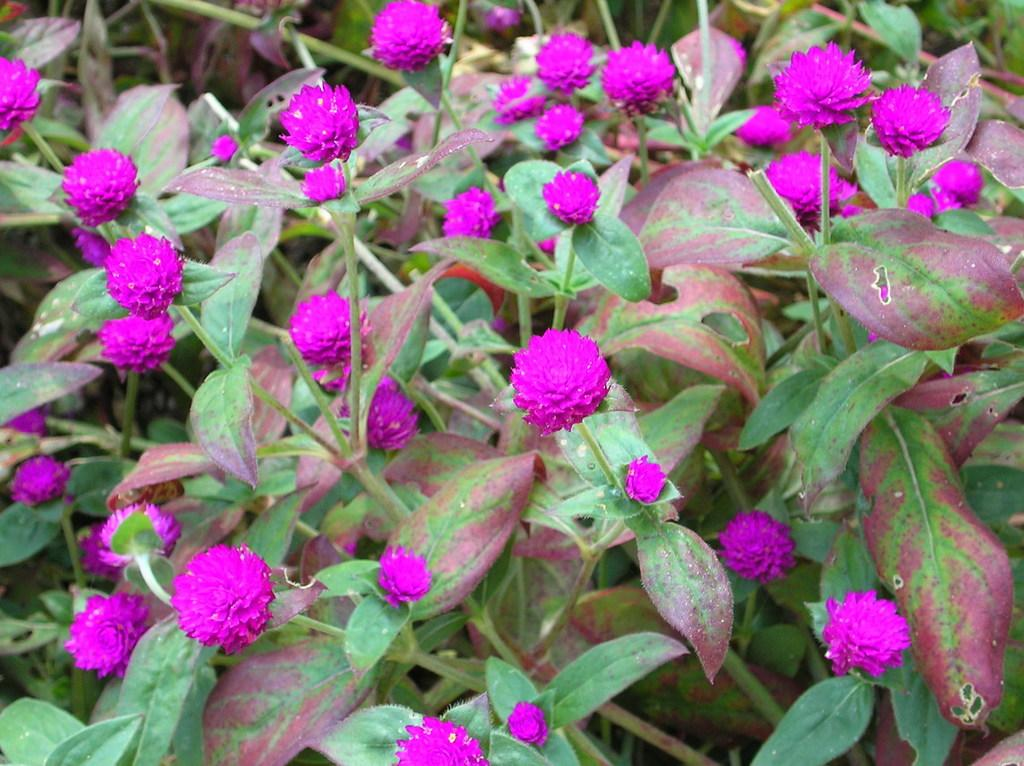What color are the flowers in the image? The flowers in the image are pink. What are the flowers growing on? The flowers are on plants. Is there a spy hiding among the flowers in the image? No, there is no spy present in the image; it only features pink flowers on plants. 